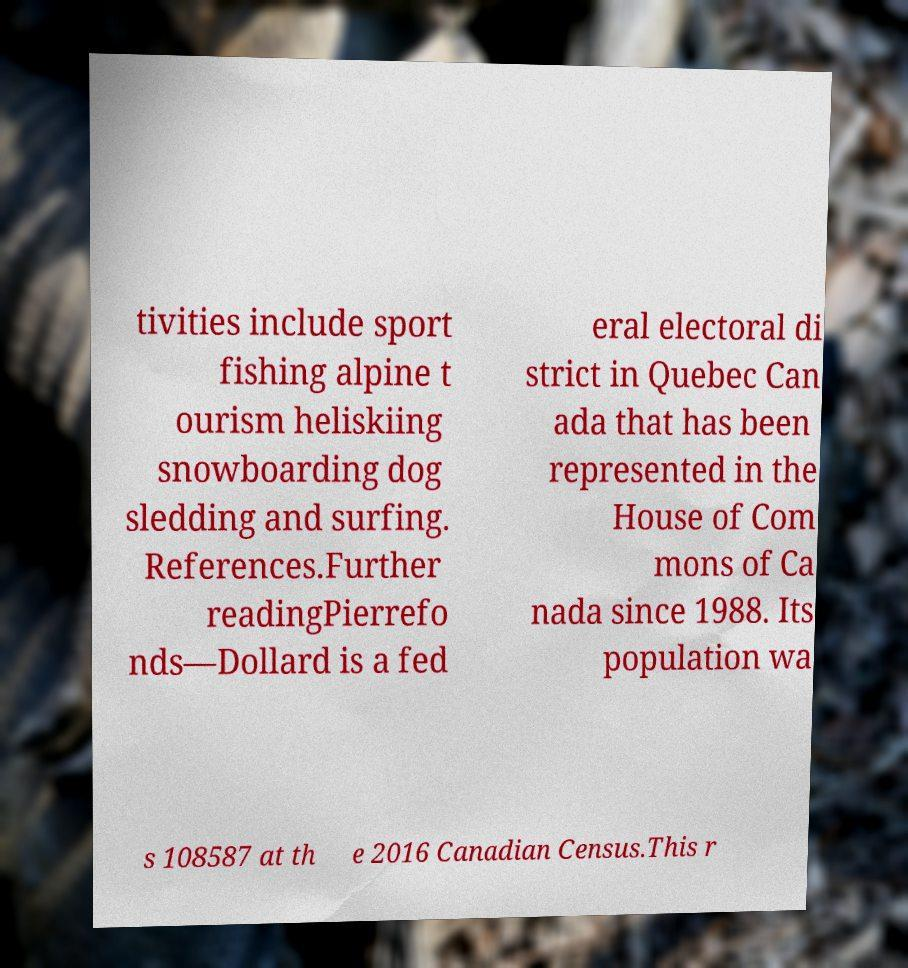Can you read and provide the text displayed in the image?This photo seems to have some interesting text. Can you extract and type it out for me? tivities include sport fishing alpine t ourism heliskiing snowboarding dog sledding and surfing. References.Further readingPierrefo nds—Dollard is a fed eral electoral di strict in Quebec Can ada that has been represented in the House of Com mons of Ca nada since 1988. Its population wa s 108587 at th e 2016 Canadian Census.This r 